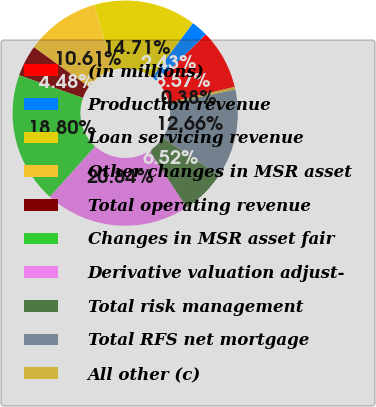Convert chart. <chart><loc_0><loc_0><loc_500><loc_500><pie_chart><fcel>(in millions)<fcel>Production revenue<fcel>Loan servicing revenue<fcel>Other changes in MSR asset<fcel>Total operating revenue<fcel>Changes in MSR asset fair<fcel>Derivative valuation adjust-<fcel>Total risk management<fcel>Total RFS net mortgage<fcel>All other (c)<nl><fcel>8.57%<fcel>2.43%<fcel>14.71%<fcel>10.61%<fcel>4.48%<fcel>18.8%<fcel>20.84%<fcel>6.52%<fcel>12.66%<fcel>0.38%<nl></chart> 